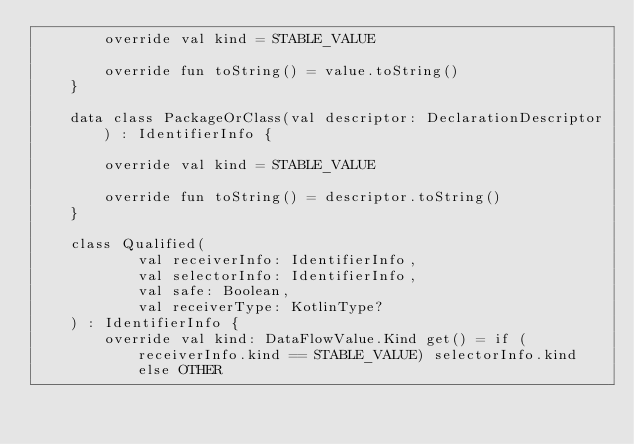Convert code to text. <code><loc_0><loc_0><loc_500><loc_500><_Kotlin_>        override val kind = STABLE_VALUE

        override fun toString() = value.toString()
    }

    data class PackageOrClass(val descriptor: DeclarationDescriptor) : IdentifierInfo {

        override val kind = STABLE_VALUE

        override fun toString() = descriptor.toString()
    }

    class Qualified(
            val receiverInfo: IdentifierInfo,
            val selectorInfo: IdentifierInfo,
            val safe: Boolean,
            val receiverType: KotlinType?
    ) : IdentifierInfo {
        override val kind: DataFlowValue.Kind get() = if (receiverInfo.kind == STABLE_VALUE) selectorInfo.kind else OTHER
</code> 